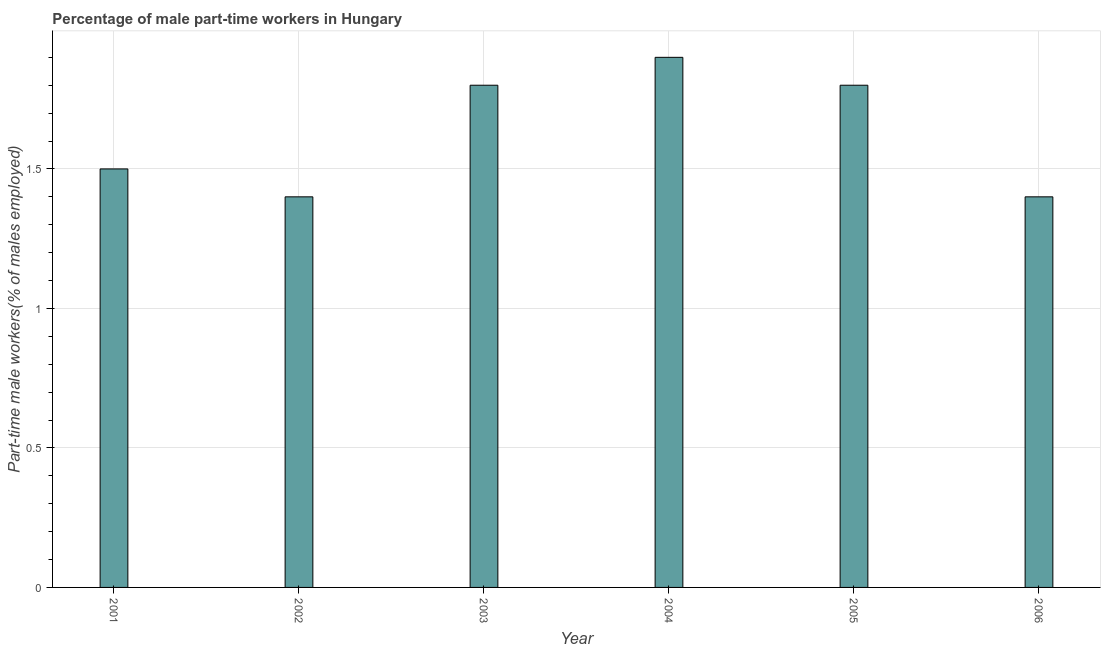Does the graph contain any zero values?
Ensure brevity in your answer.  No. Does the graph contain grids?
Ensure brevity in your answer.  Yes. What is the title of the graph?
Provide a succinct answer. Percentage of male part-time workers in Hungary. What is the label or title of the Y-axis?
Provide a short and direct response. Part-time male workers(% of males employed). What is the percentage of part-time male workers in 2006?
Give a very brief answer. 1.4. Across all years, what is the maximum percentage of part-time male workers?
Give a very brief answer. 1.9. Across all years, what is the minimum percentage of part-time male workers?
Keep it short and to the point. 1.4. In which year was the percentage of part-time male workers maximum?
Provide a succinct answer. 2004. In which year was the percentage of part-time male workers minimum?
Offer a very short reply. 2002. What is the sum of the percentage of part-time male workers?
Your answer should be very brief. 9.8. What is the average percentage of part-time male workers per year?
Provide a short and direct response. 1.63. What is the median percentage of part-time male workers?
Your response must be concise. 1.65. In how many years, is the percentage of part-time male workers greater than 1.2 %?
Make the answer very short. 6. What is the ratio of the percentage of part-time male workers in 2003 to that in 2006?
Ensure brevity in your answer.  1.29. Is the difference between the percentage of part-time male workers in 2003 and 2006 greater than the difference between any two years?
Give a very brief answer. No. In how many years, is the percentage of part-time male workers greater than the average percentage of part-time male workers taken over all years?
Offer a terse response. 3. How many bars are there?
Your answer should be compact. 6. Are all the bars in the graph horizontal?
Your answer should be compact. No. How many years are there in the graph?
Offer a very short reply. 6. What is the difference between two consecutive major ticks on the Y-axis?
Ensure brevity in your answer.  0.5. What is the Part-time male workers(% of males employed) of 2002?
Make the answer very short. 1.4. What is the Part-time male workers(% of males employed) of 2003?
Your response must be concise. 1.8. What is the Part-time male workers(% of males employed) of 2004?
Ensure brevity in your answer.  1.9. What is the Part-time male workers(% of males employed) in 2005?
Provide a succinct answer. 1.8. What is the Part-time male workers(% of males employed) in 2006?
Keep it short and to the point. 1.4. What is the difference between the Part-time male workers(% of males employed) in 2001 and 2004?
Offer a very short reply. -0.4. What is the difference between the Part-time male workers(% of males employed) in 2001 and 2005?
Provide a succinct answer. -0.3. What is the difference between the Part-time male workers(% of males employed) in 2001 and 2006?
Offer a terse response. 0.1. What is the difference between the Part-time male workers(% of males employed) in 2002 and 2004?
Provide a short and direct response. -0.5. What is the difference between the Part-time male workers(% of males employed) in 2003 and 2006?
Keep it short and to the point. 0.4. What is the difference between the Part-time male workers(% of males employed) in 2004 and 2006?
Ensure brevity in your answer.  0.5. What is the difference between the Part-time male workers(% of males employed) in 2005 and 2006?
Offer a very short reply. 0.4. What is the ratio of the Part-time male workers(% of males employed) in 2001 to that in 2002?
Provide a succinct answer. 1.07. What is the ratio of the Part-time male workers(% of males employed) in 2001 to that in 2003?
Give a very brief answer. 0.83. What is the ratio of the Part-time male workers(% of males employed) in 2001 to that in 2004?
Your answer should be very brief. 0.79. What is the ratio of the Part-time male workers(% of males employed) in 2001 to that in 2005?
Provide a short and direct response. 0.83. What is the ratio of the Part-time male workers(% of males employed) in 2001 to that in 2006?
Your answer should be very brief. 1.07. What is the ratio of the Part-time male workers(% of males employed) in 2002 to that in 2003?
Offer a very short reply. 0.78. What is the ratio of the Part-time male workers(% of males employed) in 2002 to that in 2004?
Offer a terse response. 0.74. What is the ratio of the Part-time male workers(% of males employed) in 2002 to that in 2005?
Provide a succinct answer. 0.78. What is the ratio of the Part-time male workers(% of males employed) in 2002 to that in 2006?
Provide a succinct answer. 1. What is the ratio of the Part-time male workers(% of males employed) in 2003 to that in 2004?
Your answer should be very brief. 0.95. What is the ratio of the Part-time male workers(% of males employed) in 2003 to that in 2005?
Your answer should be compact. 1. What is the ratio of the Part-time male workers(% of males employed) in 2003 to that in 2006?
Ensure brevity in your answer.  1.29. What is the ratio of the Part-time male workers(% of males employed) in 2004 to that in 2005?
Give a very brief answer. 1.06. What is the ratio of the Part-time male workers(% of males employed) in 2004 to that in 2006?
Your answer should be very brief. 1.36. What is the ratio of the Part-time male workers(% of males employed) in 2005 to that in 2006?
Your response must be concise. 1.29. 